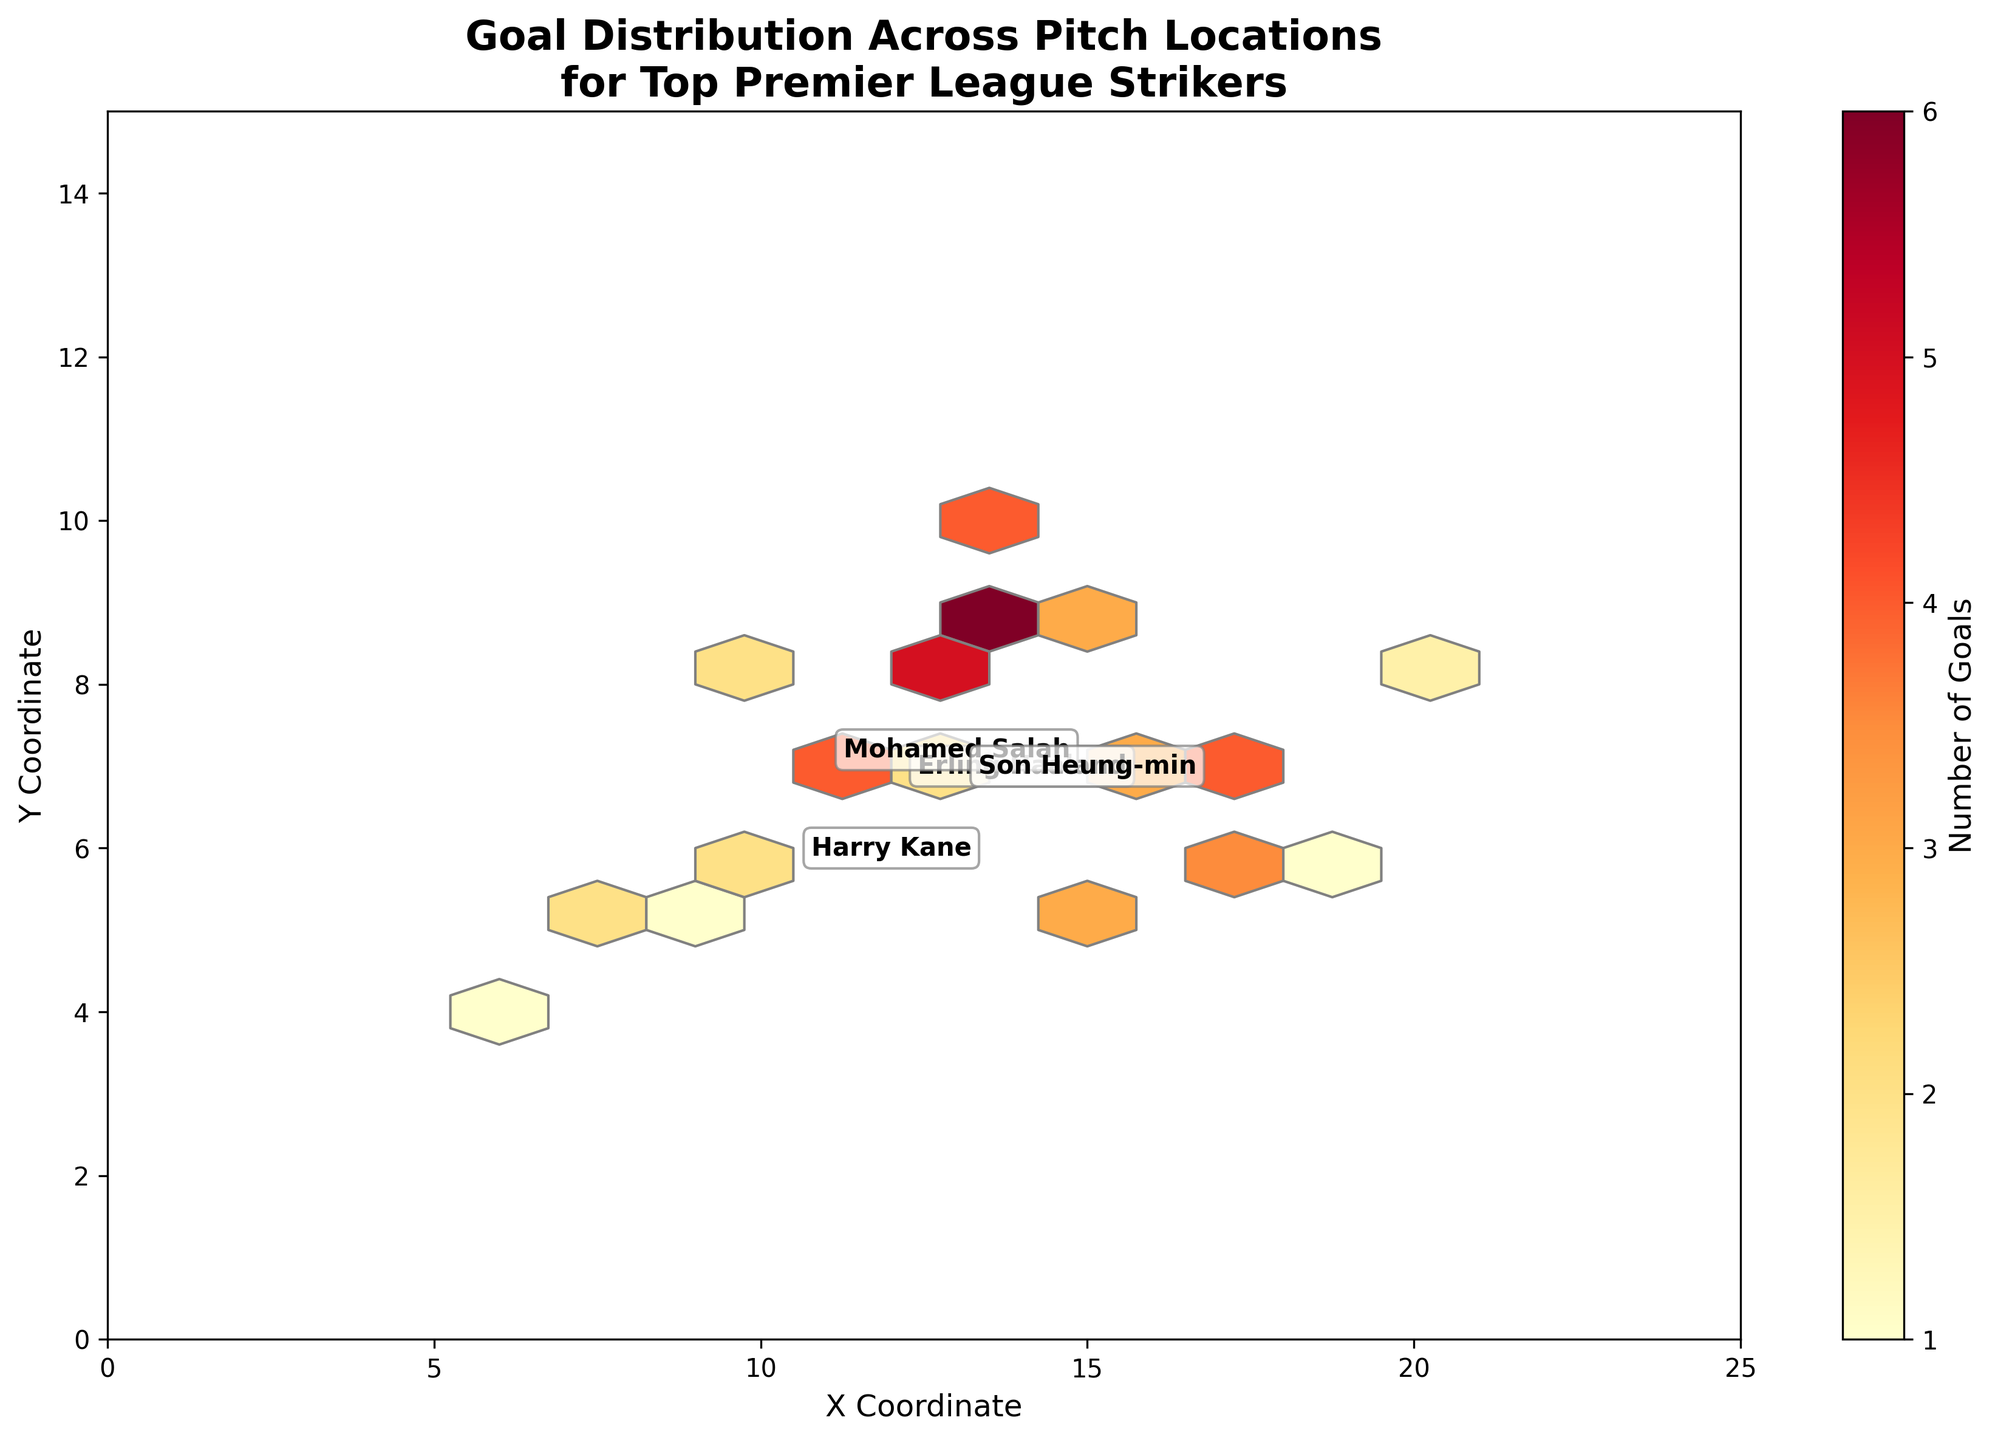What is the title of the hexbin plot? The title is clearly displayed at the top of the plot. It reads "Goal Distribution Across Pitch Locations\nfor Top Premier League Strikers"
Answer: Goal Distribution Across Pitch Locations for Top Premier League Strikers What do the X and Y axes represent in this plot? The labels on the X and Y axes indicate the coordinates on the pitch where goals were scored. The X-axis is labeled "X Coordinate" and the Y-axis is labeled "Y Coordinate".
Answer: X Coordinate and Y Coordinate Which player has the highest average goal score location towards the top right of the plot? By looking at the annotations and their relative positions, identify the player name closest to the upper right side. The annotation for Erling Haaland is closest to this area.
Answer: Erling Haaland Between Harry Kane and Mohamed Salah, who scores more goals from the center of the pitch? Find the average positions of both players. Harry Kane's annotations are closer to the center while Mohamed Salah's are more spread out. Assess the density and intensity of the hexagons.
Answer: Harry Kane What does the color intensity in hexagons represent? The color intensity in the hexagons is detailed in the colorbar; it represents the number of goals. Darker colors like deep yellow and red indicate higher goal frequencies.
Answer: Number of goals Which player has a wider spread of goal locations on the pitch, Son Heung-min or Erling Haaland? Compare the spread of hexagons and player annotations for both players. Erling Haaland's goals seem more scattered across the upper half of the pitch, while Son Heung-min's goals are more concentrated.
Answer: Erling Haaland Where is the highest concentration of goals located on the X coordinate scale? Observe the darkest hexagons along the X-axis. The highest concentration of goals seems to be around the X coordinates of 12 to 14.
Answer: Around 12 to 14 What is the significance of the color gradient ranging from light yellow to dark red? The color gradient shown along the color bar indicates that lighter yellow hexagons represent areas with fewer goals, and darker red hexagons represent areas with a higher frequency of goals.
Answer: Indicates the number of goals For each player, how are their average locations for scoring goals annotated in the plot? The average locations are shown with the player names written close to the corresponding areas on the plot. Each player's name is shown in a textbox with a slight background to enhance visibility.
Answer: Player annotations at average locations 